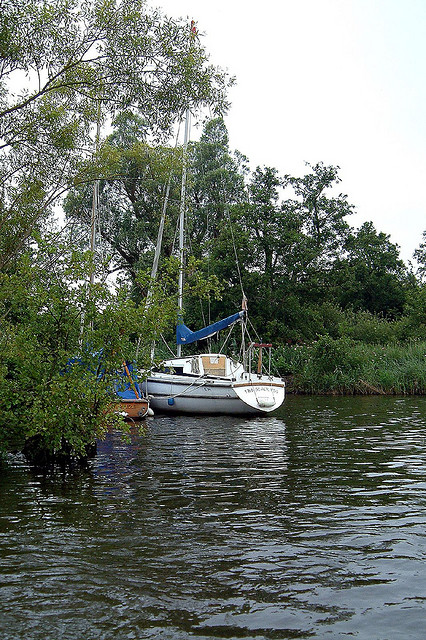<image>What is in the front boat? It is unknown what is in the front boat. It could be people, fish, chairs, or rope. What is in the front boat? I don't know what is in the front boat. It can be people, fish, chairs, or even nothing. 